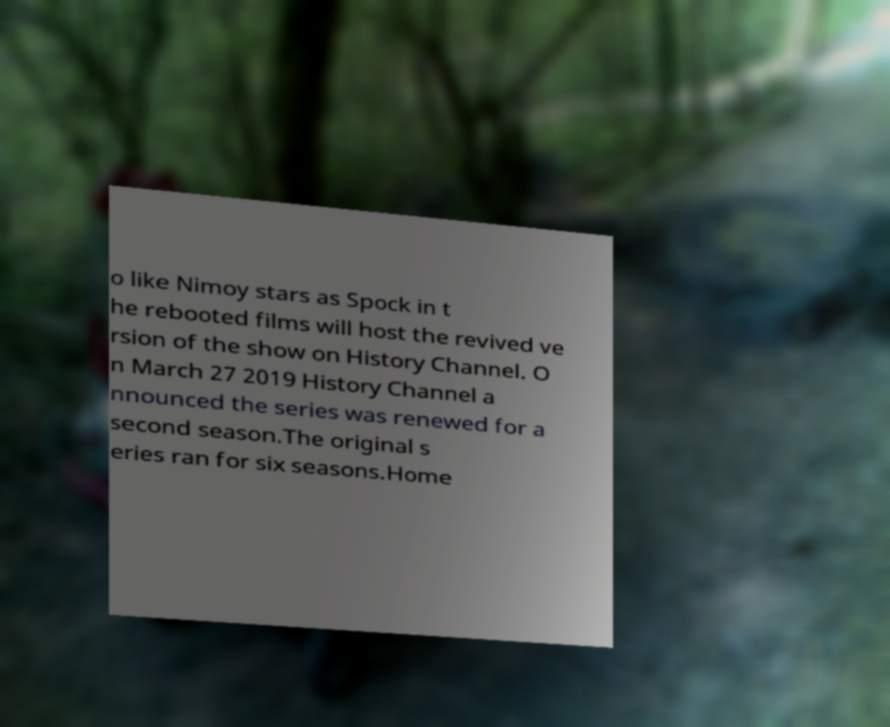Please identify and transcribe the text found in this image. o like Nimoy stars as Spock in t he rebooted films will host the revived ve rsion of the show on History Channel. O n March 27 2019 History Channel a nnounced the series was renewed for a second season.The original s eries ran for six seasons.Home 